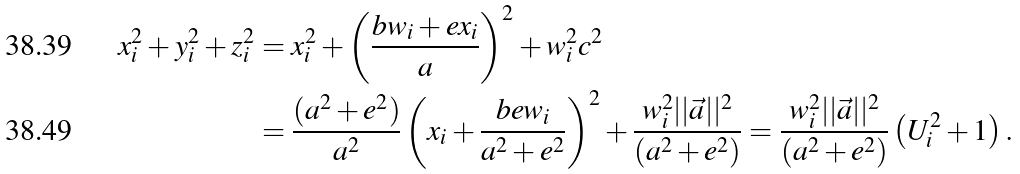<formula> <loc_0><loc_0><loc_500><loc_500>x _ { i } ^ { 2 } + y _ { i } ^ { 2 } + z _ { i } ^ { 2 } & = x _ { i } ^ { 2 } + \left ( \frac { b w _ { i } + e x _ { i } } { a } \right ) ^ { 2 } + w _ { i } ^ { 2 } c ^ { 2 } \\ & = \frac { ( a ^ { 2 } + e ^ { 2 } ) } { a ^ { 2 } } \left ( x _ { i } + \frac { b e w _ { i } } { a ^ { 2 } + e ^ { 2 } } \right ) ^ { 2 } + \frac { w _ { i } ^ { 2 } | | \vec { a } | | ^ { 2 } } { ( a ^ { 2 } + e ^ { 2 } ) } = \frac { w _ { i } ^ { 2 } | | \vec { a } | | ^ { 2 } } { ( a ^ { 2 } + e ^ { 2 } ) } \left ( U _ { i } ^ { 2 } + 1 \right ) .</formula> 